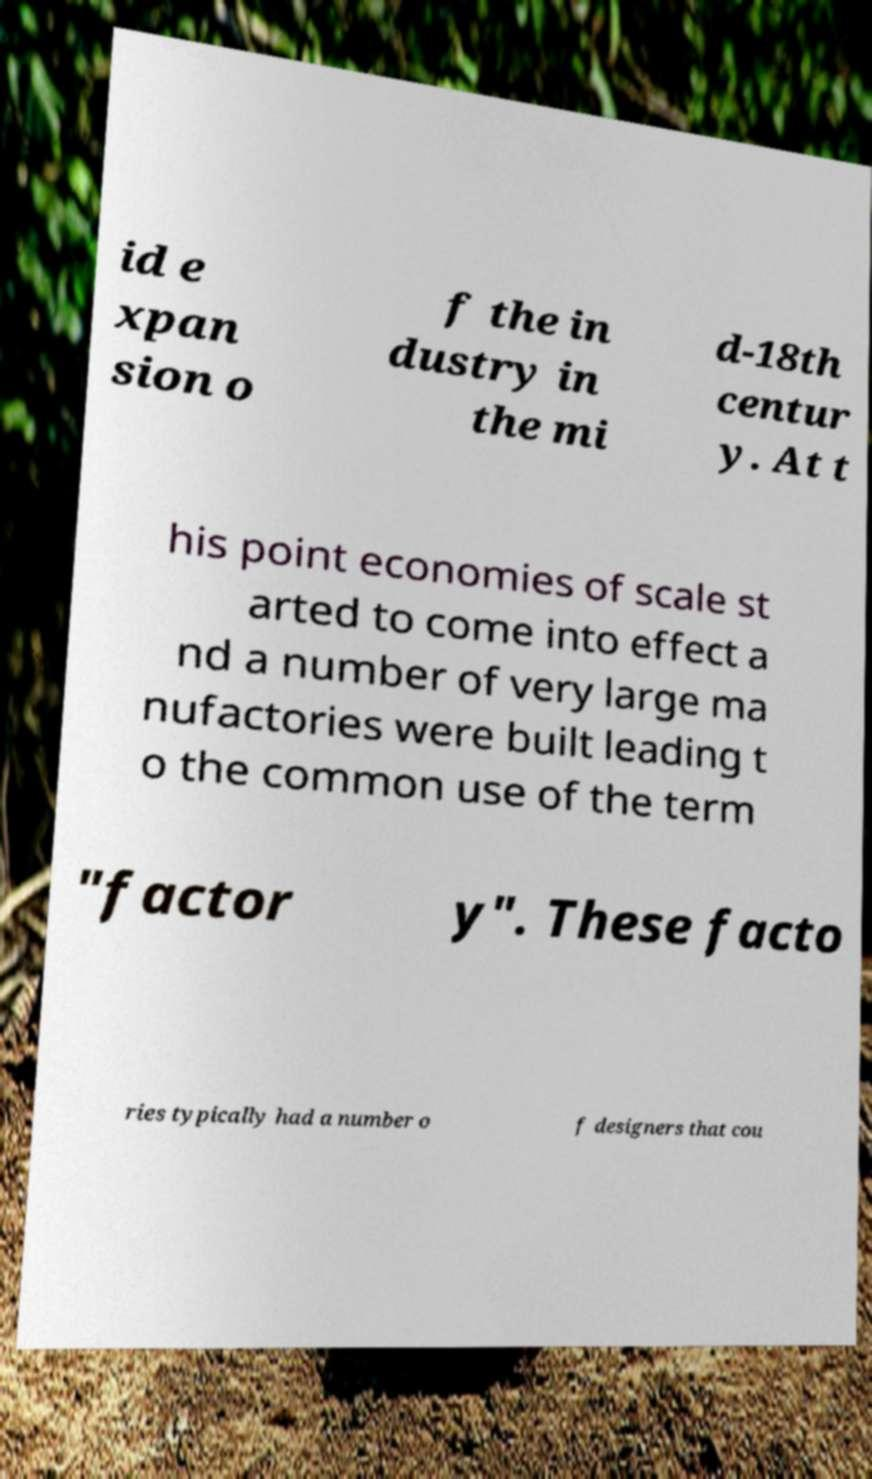There's text embedded in this image that I need extracted. Can you transcribe it verbatim? id e xpan sion o f the in dustry in the mi d-18th centur y. At t his point economies of scale st arted to come into effect a nd a number of very large ma nufactories were built leading t o the common use of the term "factor y". These facto ries typically had a number o f designers that cou 